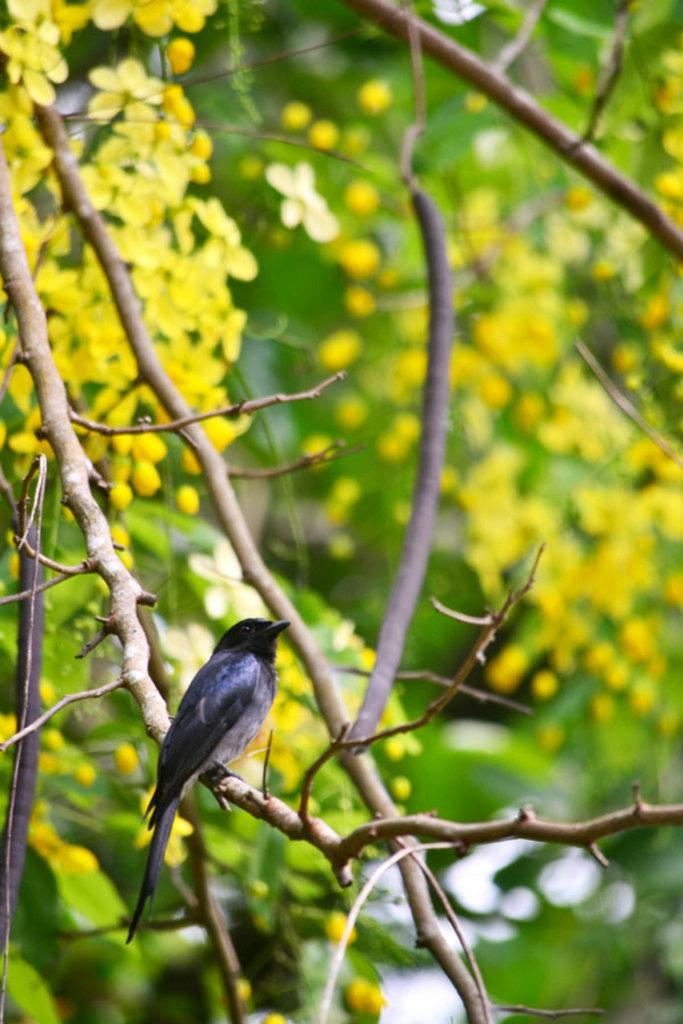What is the main subject in the center of the image? There are trees, plants, and branches in the center of the image. Are there any animals visible in the image? Yes, there is a bird on one of the branches. What can you tell about the bird's appearance? The bird is in black and white color. What type of coal can be seen in the image? There is no coal present in the image. How does the bird's behavior change throughout the image? The image is a still photograph, so it does not show any changes in the bird's behavior. 